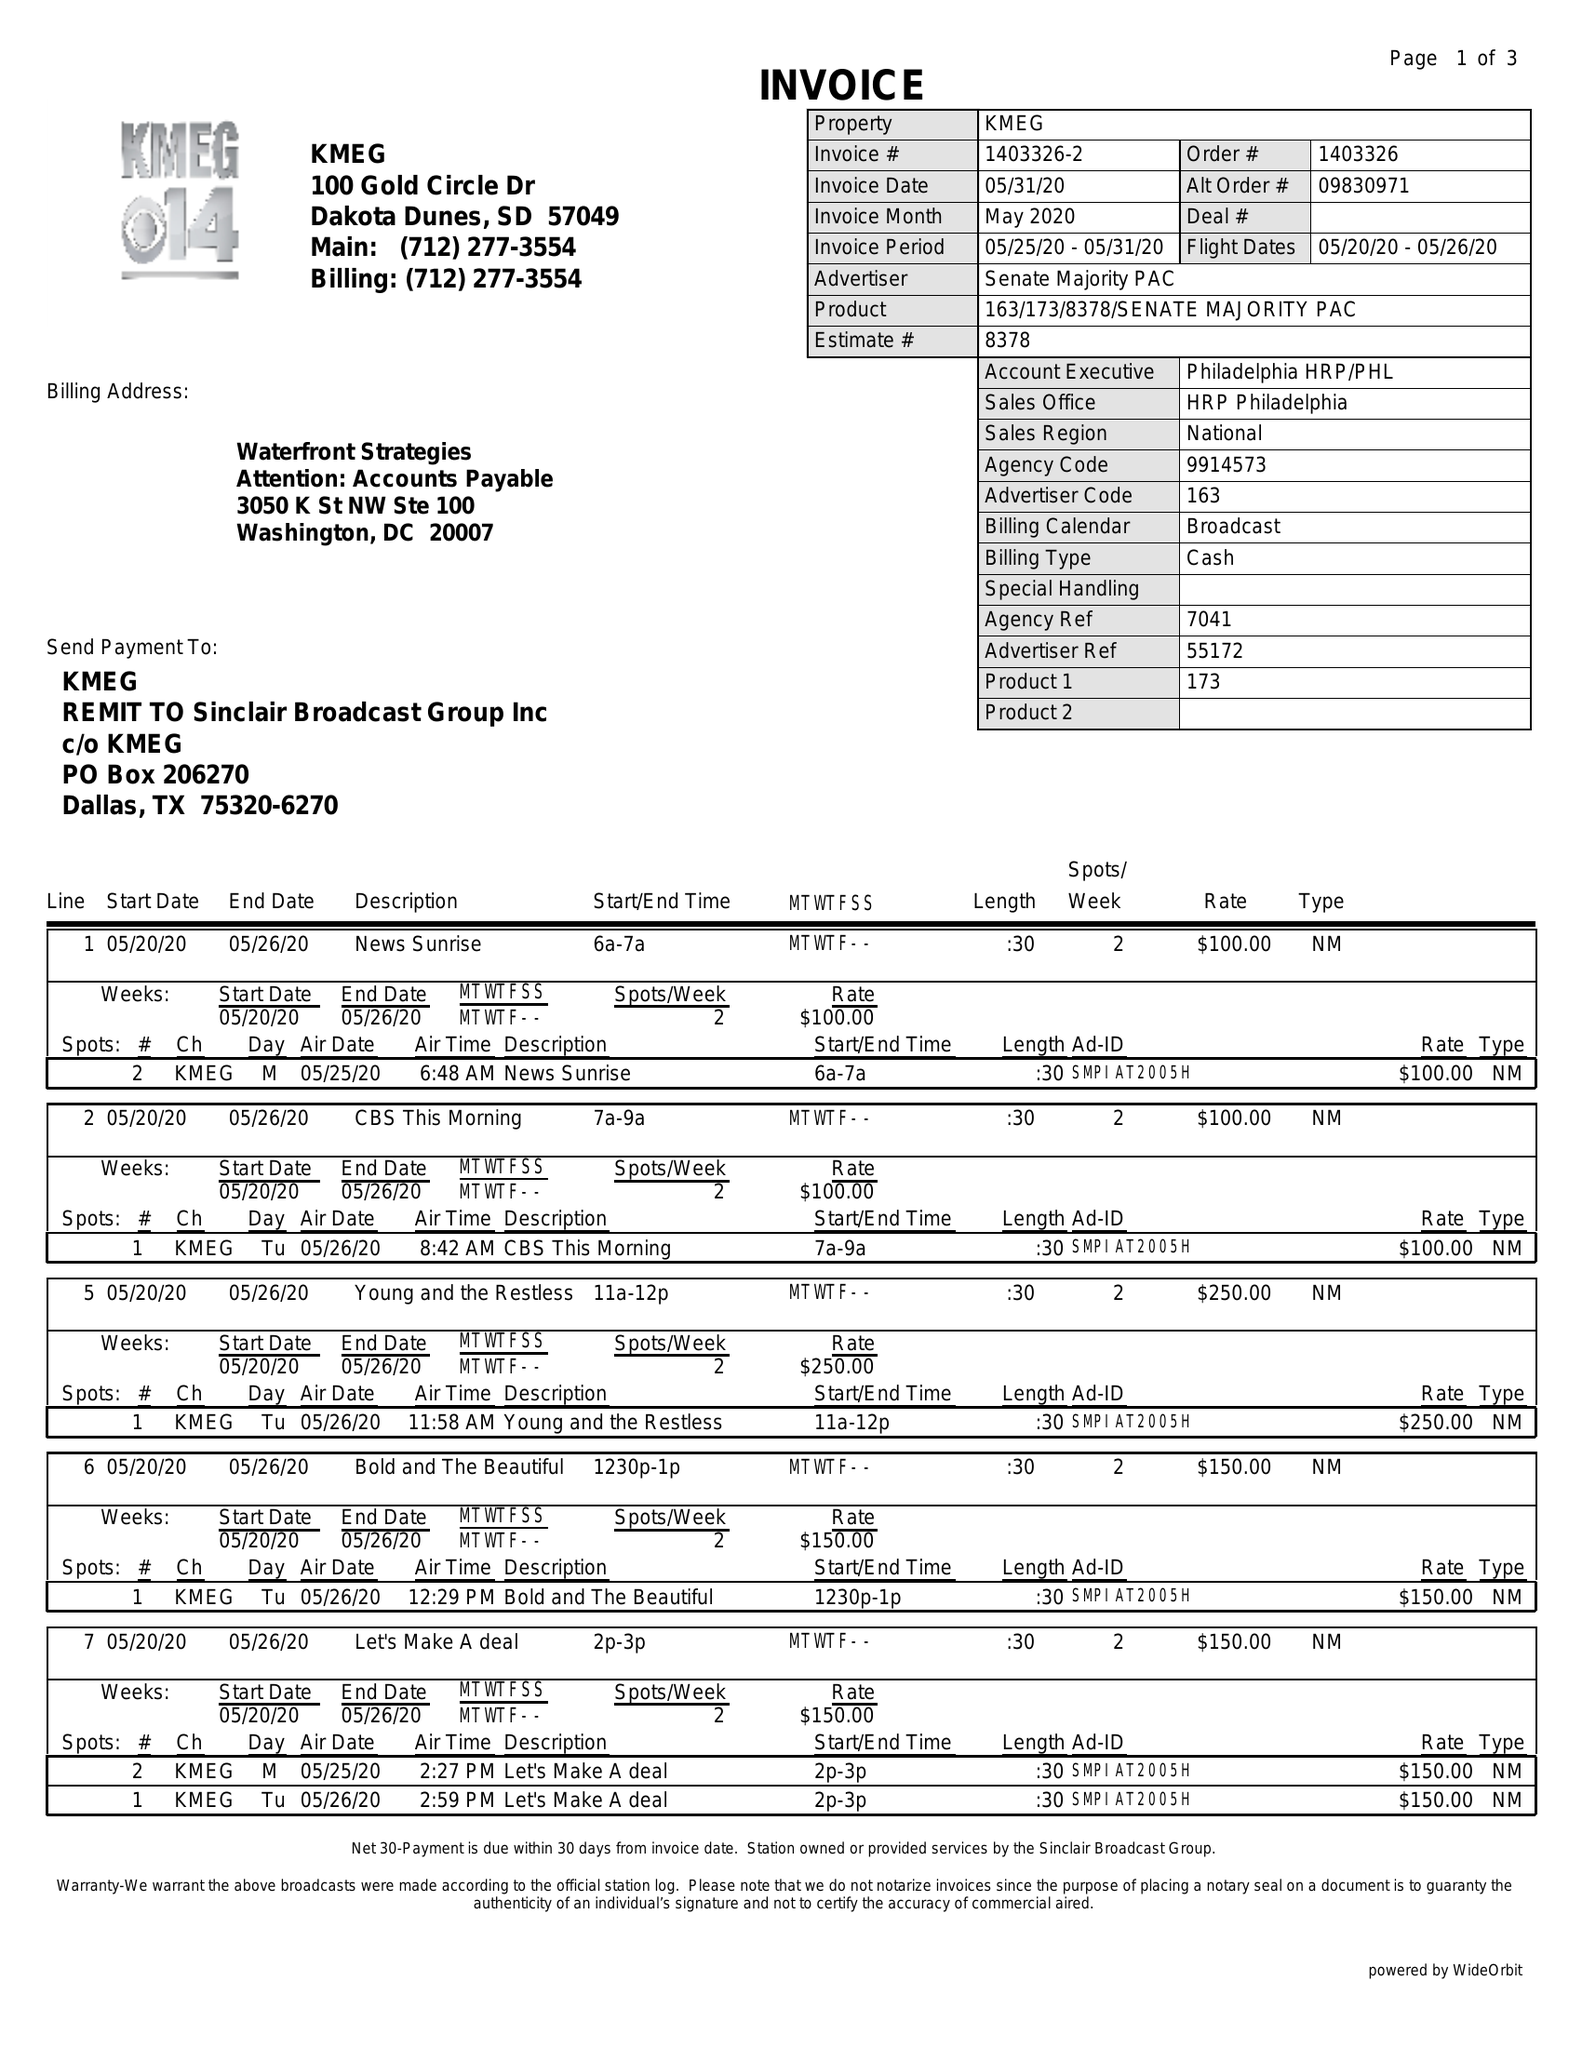What is the value for the advertiser?
Answer the question using a single word or phrase. SENATE MAJORITY PAC 